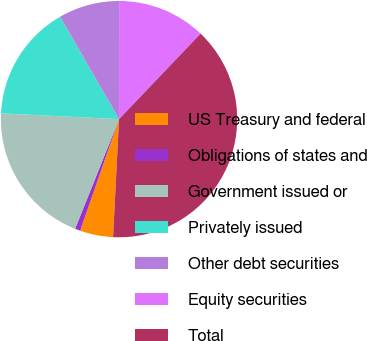Convert chart to OTSL. <chart><loc_0><loc_0><loc_500><loc_500><pie_chart><fcel>US Treasury and federal<fcel>Obligations of states and<fcel>Government issued or<fcel>Privately issued<fcel>Other debt securities<fcel>Equity securities<fcel>Total<nl><fcel>4.53%<fcel>0.73%<fcel>19.71%<fcel>15.91%<fcel>8.32%<fcel>12.12%<fcel>38.68%<nl></chart> 